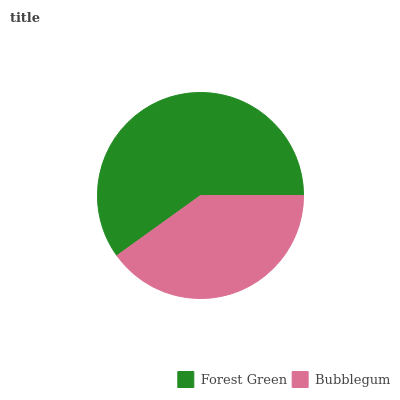Is Bubblegum the minimum?
Answer yes or no. Yes. Is Forest Green the maximum?
Answer yes or no. Yes. Is Bubblegum the maximum?
Answer yes or no. No. Is Forest Green greater than Bubblegum?
Answer yes or no. Yes. Is Bubblegum less than Forest Green?
Answer yes or no. Yes. Is Bubblegum greater than Forest Green?
Answer yes or no. No. Is Forest Green less than Bubblegum?
Answer yes or no. No. Is Forest Green the high median?
Answer yes or no. Yes. Is Bubblegum the low median?
Answer yes or no. Yes. Is Bubblegum the high median?
Answer yes or no. No. Is Forest Green the low median?
Answer yes or no. No. 